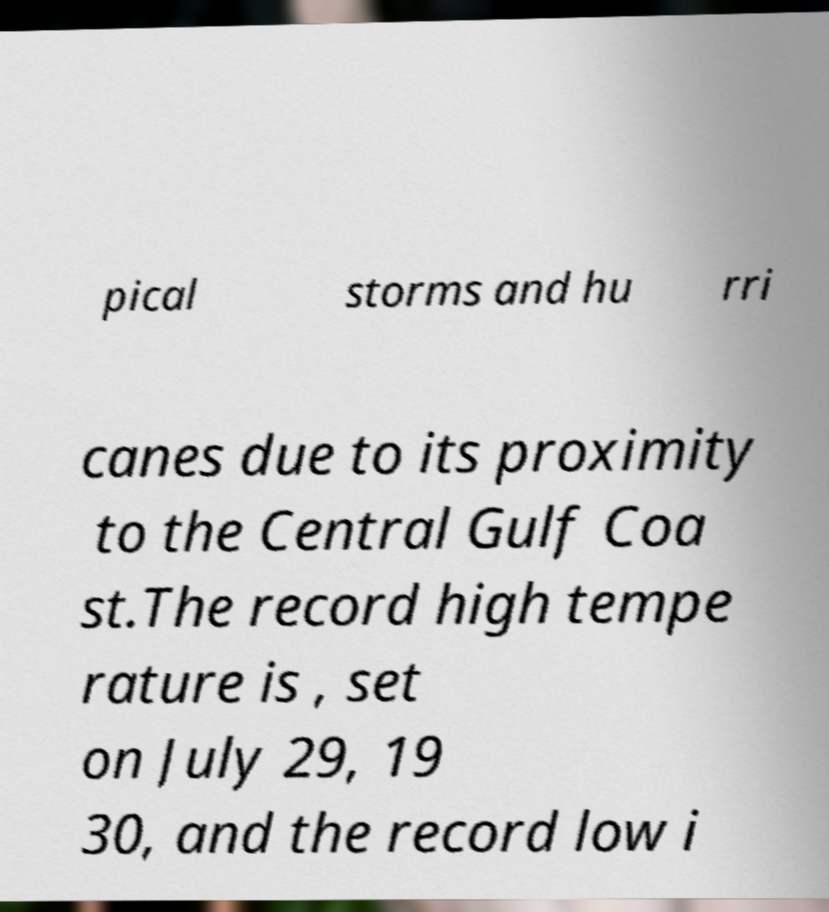Please read and relay the text visible in this image. What does it say? pical storms and hu rri canes due to its proximity to the Central Gulf Coa st.The record high tempe rature is , set on July 29, 19 30, and the record low i 